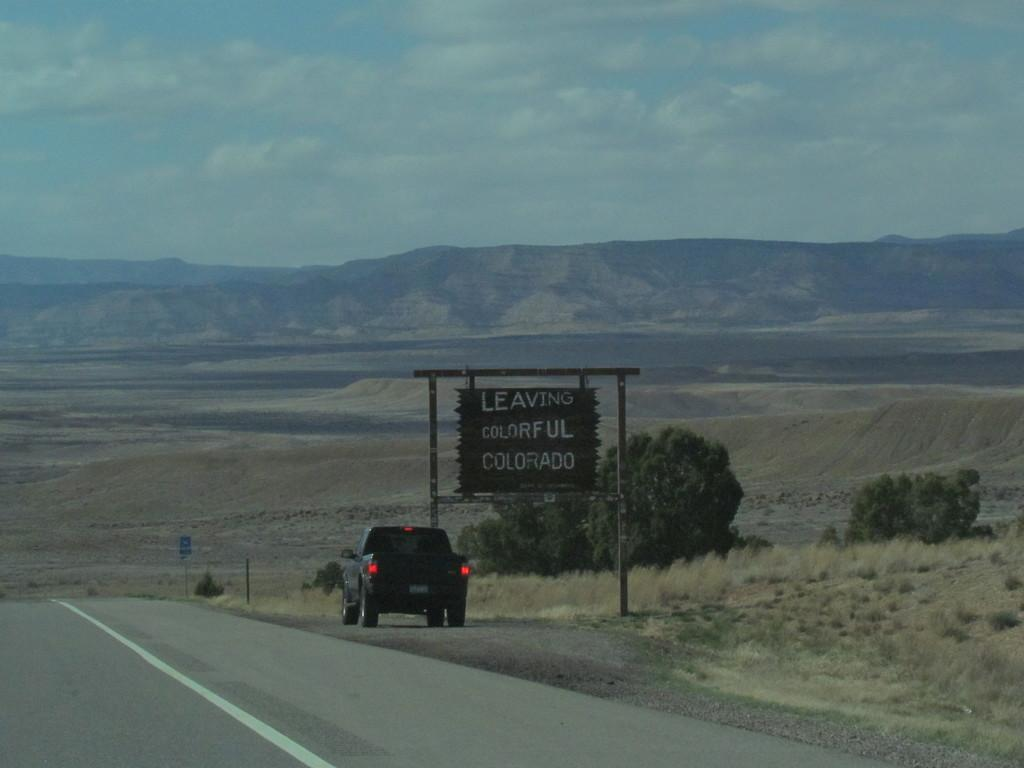What is the main subject of the image? There is a car on the road in the image. What can be seen in the background of the image? There are trees, a board, plants, hills, and the sky visible in the background of the image. What is the condition of the sky in the image? The sky is visible in the background of the image, and there are clouds present. What type of bucket is being used in the argument between the crow and the car in the image? There is no bucket, crow, or argument present in the image. 